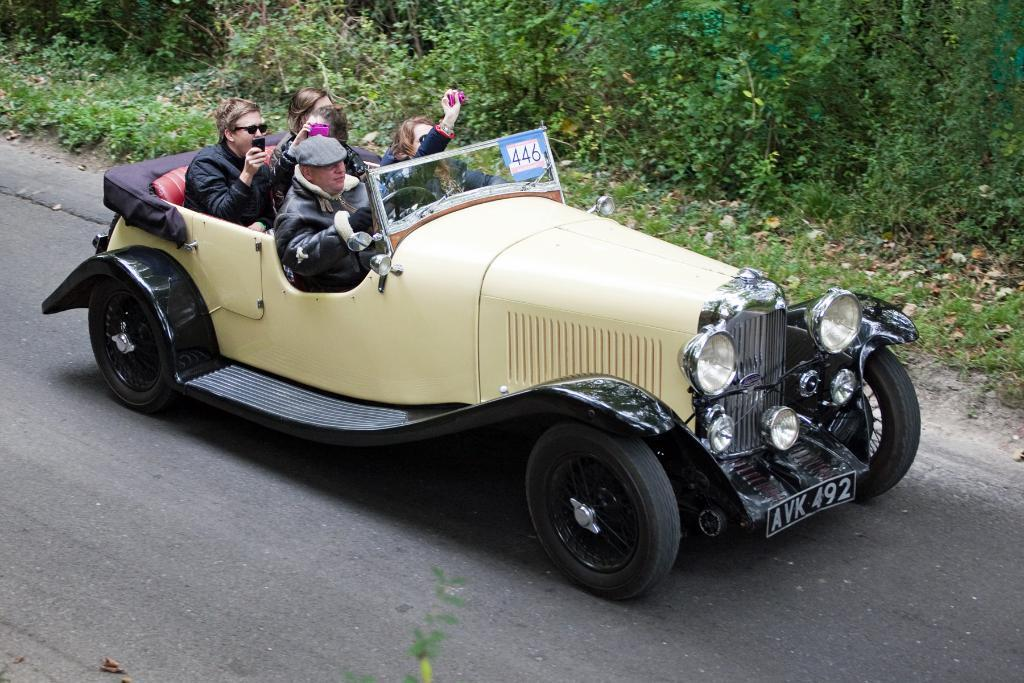How many people are in the image? There is a group of people in the image. What are the people doing in the image? The people are traveling in a vintage car. Where is the car located in the image? The car is on a road. What can be seen beside the road in the image? There are plants present beside the road. Can you see a kite flying in the image? No, there is no kite present in the image. Are the people kicking a ball while traveling in the car? No, the people are not kicking a ball in the image; they are traveling in a vintage car. 